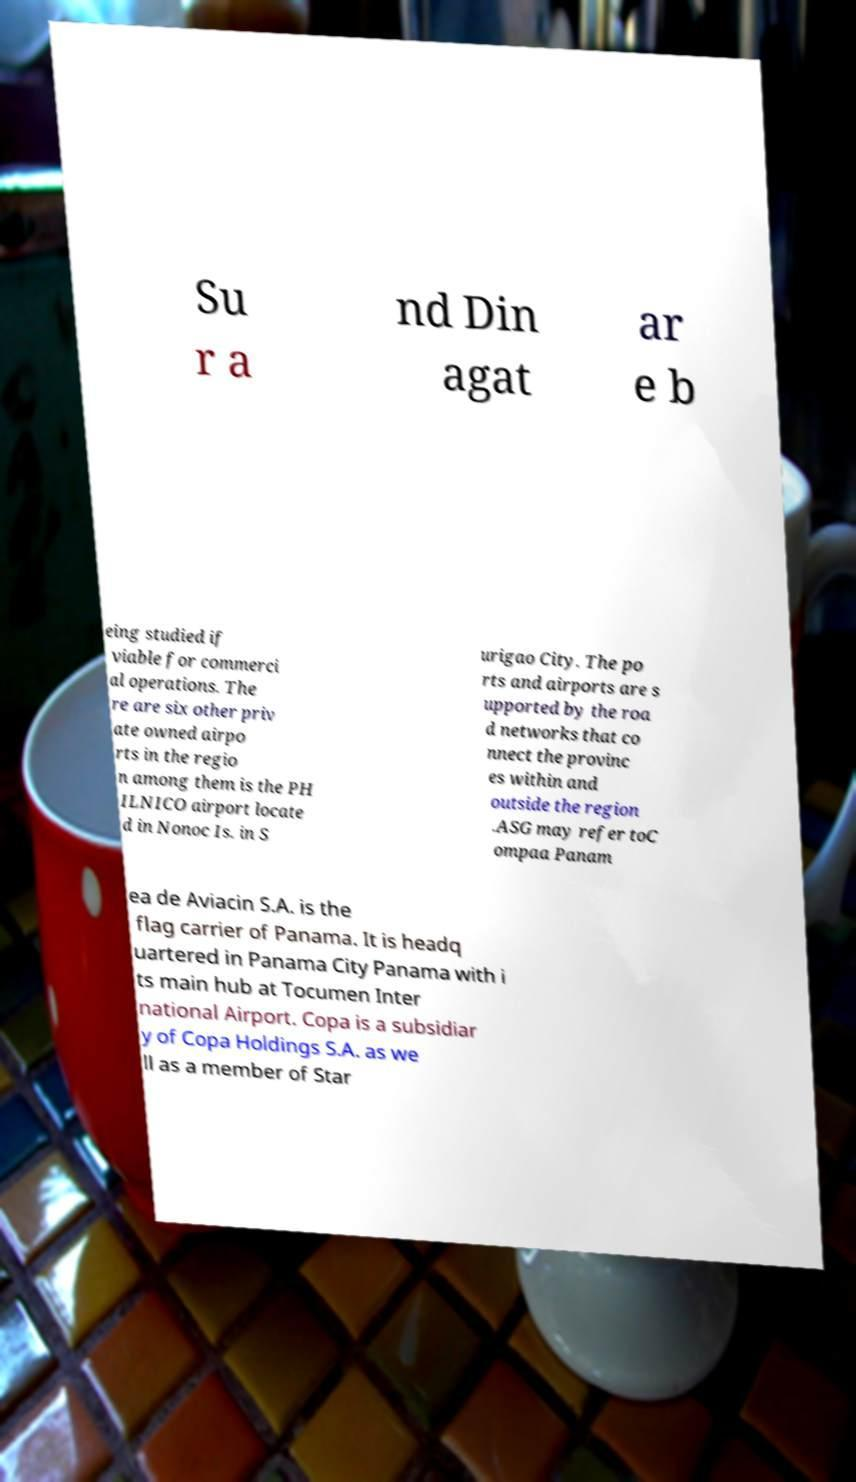Can you read and provide the text displayed in the image?This photo seems to have some interesting text. Can you extract and type it out for me? Su r a nd Din agat ar e b eing studied if viable for commerci al operations. The re are six other priv ate owned airpo rts in the regio n among them is the PH ILNICO airport locate d in Nonoc Is. in S urigao City. The po rts and airports are s upported by the roa d networks that co nnect the provinc es within and outside the region .ASG may refer toC ompaa Panam ea de Aviacin S.A. is the flag carrier of Panama. It is headq uartered in Panama City Panama with i ts main hub at Tocumen Inter national Airport. Copa is a subsidiar y of Copa Holdings S.A. as we ll as a member of Star 